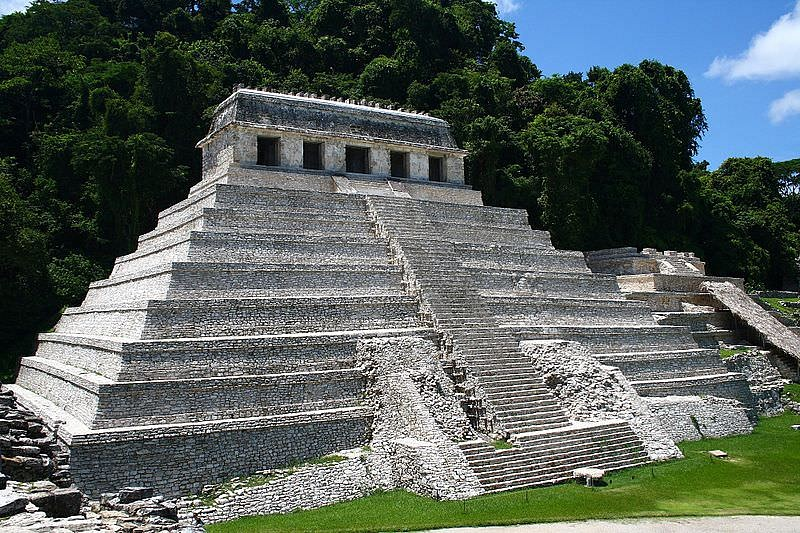How does this structure reflect the technological advancements of the Mayan civilization? The Temple of Inscriptions is a testament to the advanced architectural and engineering skills of the Mayans. Its precise geometric proportions and the durability of its construction, employing mortar-less limestone blocks, reflect a deep understanding of architectural principles. The choice of materials and the pyramid's strategic positioning within its surroundings suggest a sophisticated knowledge of geological and environmental factors. Additionally, the internal staircase leading to the tomb of King Pakal, equipped with a unique psychoduct system designed to channel the voice of the deceased king, demonstrates an innovative approach to architecture that integrates functionality, religious significance, and technological ingenuity. 